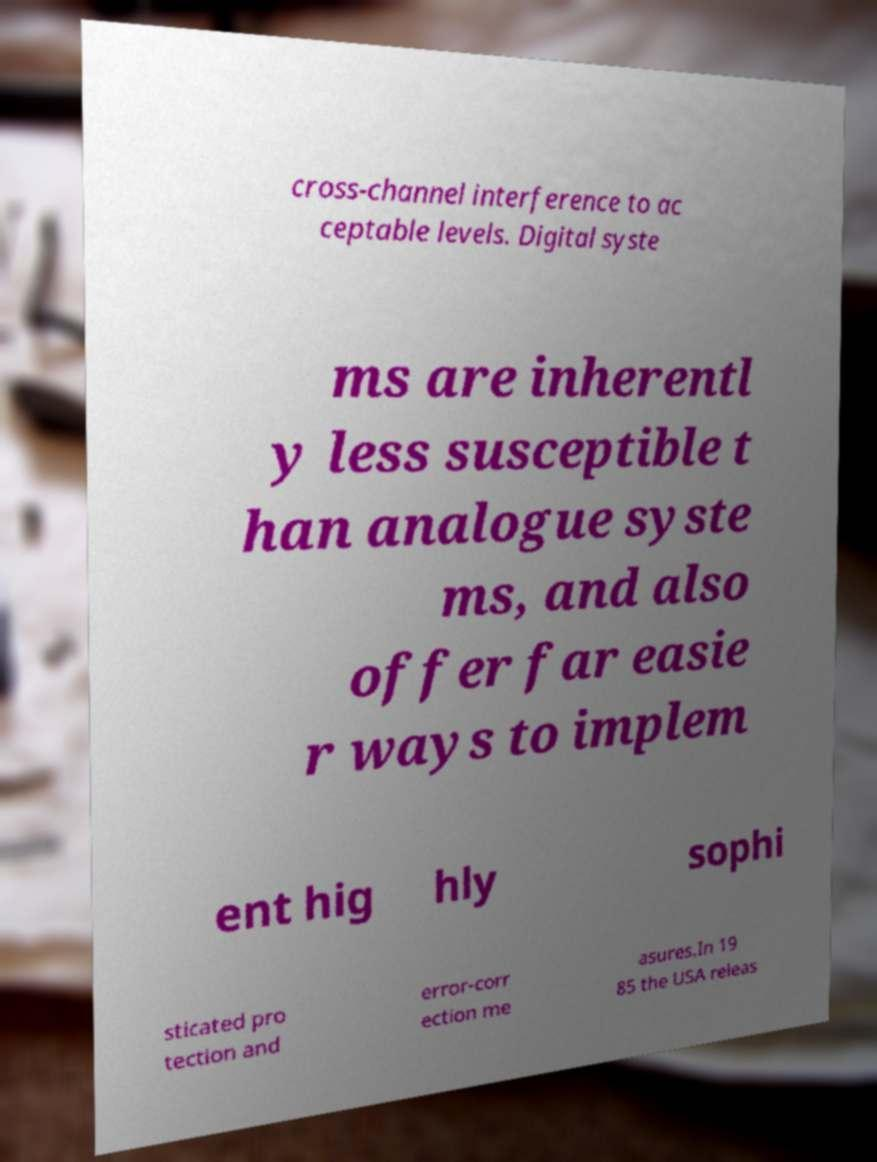Can you accurately transcribe the text from the provided image for me? cross-channel interference to ac ceptable levels. Digital syste ms are inherentl y less susceptible t han analogue syste ms, and also offer far easie r ways to implem ent hig hly sophi sticated pro tection and error-corr ection me asures.In 19 85 the USA releas 